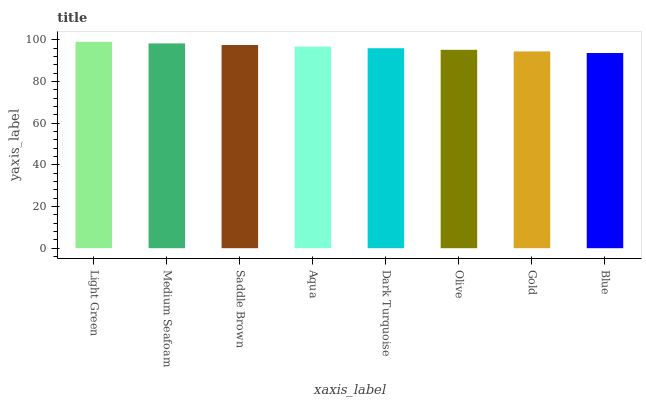Is Blue the minimum?
Answer yes or no. Yes. Is Light Green the maximum?
Answer yes or no. Yes. Is Medium Seafoam the minimum?
Answer yes or no. No. Is Medium Seafoam the maximum?
Answer yes or no. No. Is Light Green greater than Medium Seafoam?
Answer yes or no. Yes. Is Medium Seafoam less than Light Green?
Answer yes or no. Yes. Is Medium Seafoam greater than Light Green?
Answer yes or no. No. Is Light Green less than Medium Seafoam?
Answer yes or no. No. Is Aqua the high median?
Answer yes or no. Yes. Is Dark Turquoise the low median?
Answer yes or no. Yes. Is Medium Seafoam the high median?
Answer yes or no. No. Is Olive the low median?
Answer yes or no. No. 